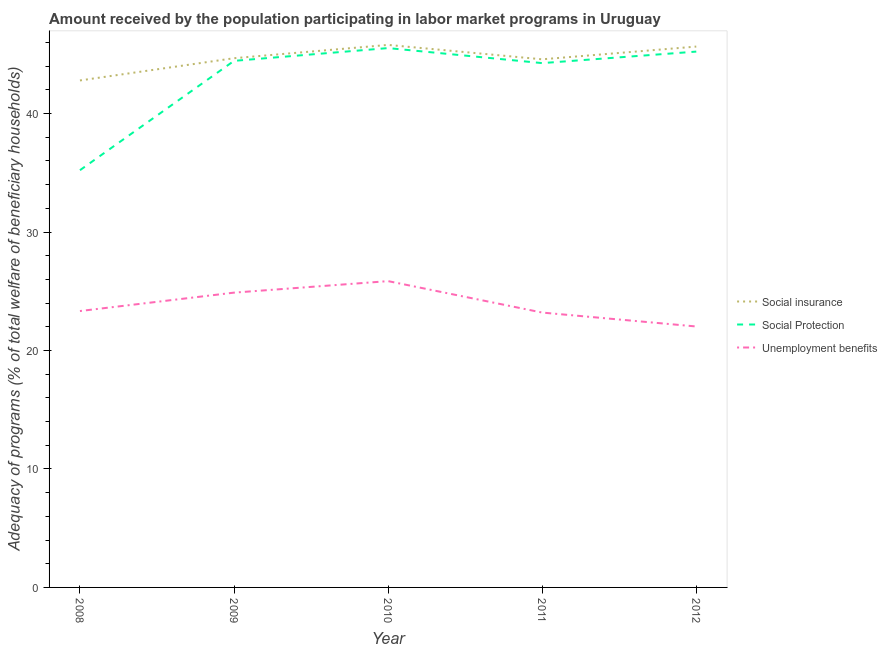How many different coloured lines are there?
Offer a terse response. 3. Does the line corresponding to amount received by the population participating in social protection programs intersect with the line corresponding to amount received by the population participating in social insurance programs?
Offer a very short reply. No. What is the amount received by the population participating in unemployment benefits programs in 2009?
Ensure brevity in your answer.  24.89. Across all years, what is the maximum amount received by the population participating in social protection programs?
Offer a very short reply. 45.53. Across all years, what is the minimum amount received by the population participating in social protection programs?
Provide a succinct answer. 35.22. In which year was the amount received by the population participating in social protection programs maximum?
Make the answer very short. 2010. What is the total amount received by the population participating in social insurance programs in the graph?
Offer a very short reply. 223.52. What is the difference between the amount received by the population participating in unemployment benefits programs in 2008 and that in 2010?
Give a very brief answer. -2.53. What is the difference between the amount received by the population participating in social protection programs in 2012 and the amount received by the population participating in social insurance programs in 2009?
Your answer should be very brief. 0.56. What is the average amount received by the population participating in unemployment benefits programs per year?
Your answer should be very brief. 23.86. In the year 2012, what is the difference between the amount received by the population participating in social protection programs and amount received by the population participating in unemployment benefits programs?
Ensure brevity in your answer.  23.21. What is the ratio of the amount received by the population participating in social protection programs in 2009 to that in 2012?
Make the answer very short. 0.98. Is the amount received by the population participating in unemployment benefits programs in 2010 less than that in 2011?
Your answer should be very brief. No. Is the difference between the amount received by the population participating in unemployment benefits programs in 2008 and 2011 greater than the difference between the amount received by the population participating in social protection programs in 2008 and 2011?
Your answer should be very brief. Yes. What is the difference between the highest and the second highest amount received by the population participating in social protection programs?
Make the answer very short. 0.3. What is the difference between the highest and the lowest amount received by the population participating in unemployment benefits programs?
Keep it short and to the point. 3.83. Is the sum of the amount received by the population participating in social insurance programs in 2009 and 2011 greater than the maximum amount received by the population participating in unemployment benefits programs across all years?
Your answer should be very brief. Yes. Does the amount received by the population participating in social protection programs monotonically increase over the years?
Offer a very short reply. No. How many years are there in the graph?
Your response must be concise. 5. Are the values on the major ticks of Y-axis written in scientific E-notation?
Keep it short and to the point. No. Does the graph contain grids?
Give a very brief answer. No. What is the title of the graph?
Offer a very short reply. Amount received by the population participating in labor market programs in Uruguay. What is the label or title of the Y-axis?
Ensure brevity in your answer.  Adequacy of programs (% of total welfare of beneficiary households). What is the Adequacy of programs (% of total welfare of beneficiary households) in Social insurance in 2008?
Give a very brief answer. 42.8. What is the Adequacy of programs (% of total welfare of beneficiary households) of Social Protection in 2008?
Your response must be concise. 35.22. What is the Adequacy of programs (% of total welfare of beneficiary households) in Unemployment benefits in 2008?
Offer a very short reply. 23.33. What is the Adequacy of programs (% of total welfare of beneficiary households) in Social insurance in 2009?
Provide a short and direct response. 44.68. What is the Adequacy of programs (% of total welfare of beneficiary households) in Social Protection in 2009?
Make the answer very short. 44.45. What is the Adequacy of programs (% of total welfare of beneficiary households) of Unemployment benefits in 2009?
Give a very brief answer. 24.89. What is the Adequacy of programs (% of total welfare of beneficiary households) in Social insurance in 2010?
Ensure brevity in your answer.  45.8. What is the Adequacy of programs (% of total welfare of beneficiary households) of Social Protection in 2010?
Provide a succinct answer. 45.53. What is the Adequacy of programs (% of total welfare of beneficiary households) in Unemployment benefits in 2010?
Your response must be concise. 25.86. What is the Adequacy of programs (% of total welfare of beneficiary households) in Social insurance in 2011?
Give a very brief answer. 44.58. What is the Adequacy of programs (% of total welfare of beneficiary households) of Social Protection in 2011?
Ensure brevity in your answer.  44.26. What is the Adequacy of programs (% of total welfare of beneficiary households) in Unemployment benefits in 2011?
Offer a terse response. 23.2. What is the Adequacy of programs (% of total welfare of beneficiary households) of Social insurance in 2012?
Provide a succinct answer. 45.66. What is the Adequacy of programs (% of total welfare of beneficiary households) of Social Protection in 2012?
Offer a very short reply. 45.24. What is the Adequacy of programs (% of total welfare of beneficiary households) in Unemployment benefits in 2012?
Your answer should be very brief. 22.03. Across all years, what is the maximum Adequacy of programs (% of total welfare of beneficiary households) of Social insurance?
Keep it short and to the point. 45.8. Across all years, what is the maximum Adequacy of programs (% of total welfare of beneficiary households) of Social Protection?
Your response must be concise. 45.53. Across all years, what is the maximum Adequacy of programs (% of total welfare of beneficiary households) of Unemployment benefits?
Ensure brevity in your answer.  25.86. Across all years, what is the minimum Adequacy of programs (% of total welfare of beneficiary households) in Social insurance?
Provide a succinct answer. 42.8. Across all years, what is the minimum Adequacy of programs (% of total welfare of beneficiary households) of Social Protection?
Your answer should be compact. 35.22. Across all years, what is the minimum Adequacy of programs (% of total welfare of beneficiary households) of Unemployment benefits?
Your answer should be very brief. 22.03. What is the total Adequacy of programs (% of total welfare of beneficiary households) of Social insurance in the graph?
Make the answer very short. 223.52. What is the total Adequacy of programs (% of total welfare of beneficiary households) of Social Protection in the graph?
Your answer should be compact. 214.71. What is the total Adequacy of programs (% of total welfare of beneficiary households) in Unemployment benefits in the graph?
Provide a short and direct response. 119.31. What is the difference between the Adequacy of programs (% of total welfare of beneficiary households) in Social insurance in 2008 and that in 2009?
Your answer should be very brief. -1.88. What is the difference between the Adequacy of programs (% of total welfare of beneficiary households) in Social Protection in 2008 and that in 2009?
Keep it short and to the point. -9.23. What is the difference between the Adequacy of programs (% of total welfare of beneficiary households) in Unemployment benefits in 2008 and that in 2009?
Ensure brevity in your answer.  -1.55. What is the difference between the Adequacy of programs (% of total welfare of beneficiary households) of Social insurance in 2008 and that in 2010?
Offer a terse response. -3. What is the difference between the Adequacy of programs (% of total welfare of beneficiary households) of Social Protection in 2008 and that in 2010?
Make the answer very short. -10.31. What is the difference between the Adequacy of programs (% of total welfare of beneficiary households) of Unemployment benefits in 2008 and that in 2010?
Your response must be concise. -2.53. What is the difference between the Adequacy of programs (% of total welfare of beneficiary households) in Social insurance in 2008 and that in 2011?
Your answer should be very brief. -1.78. What is the difference between the Adequacy of programs (% of total welfare of beneficiary households) of Social Protection in 2008 and that in 2011?
Your answer should be very brief. -9.04. What is the difference between the Adequacy of programs (% of total welfare of beneficiary households) of Unemployment benefits in 2008 and that in 2011?
Offer a very short reply. 0.13. What is the difference between the Adequacy of programs (% of total welfare of beneficiary households) in Social insurance in 2008 and that in 2012?
Ensure brevity in your answer.  -2.86. What is the difference between the Adequacy of programs (% of total welfare of beneficiary households) in Social Protection in 2008 and that in 2012?
Your answer should be compact. -10.01. What is the difference between the Adequacy of programs (% of total welfare of beneficiary households) in Unemployment benefits in 2008 and that in 2012?
Make the answer very short. 1.3. What is the difference between the Adequacy of programs (% of total welfare of beneficiary households) in Social insurance in 2009 and that in 2010?
Your response must be concise. -1.12. What is the difference between the Adequacy of programs (% of total welfare of beneficiary households) in Social Protection in 2009 and that in 2010?
Keep it short and to the point. -1.08. What is the difference between the Adequacy of programs (% of total welfare of beneficiary households) of Unemployment benefits in 2009 and that in 2010?
Ensure brevity in your answer.  -0.97. What is the difference between the Adequacy of programs (% of total welfare of beneficiary households) in Social insurance in 2009 and that in 2011?
Your response must be concise. 0.09. What is the difference between the Adequacy of programs (% of total welfare of beneficiary households) in Social Protection in 2009 and that in 2011?
Give a very brief answer. 0.19. What is the difference between the Adequacy of programs (% of total welfare of beneficiary households) in Unemployment benefits in 2009 and that in 2011?
Give a very brief answer. 1.68. What is the difference between the Adequacy of programs (% of total welfare of beneficiary households) of Social insurance in 2009 and that in 2012?
Give a very brief answer. -0.98. What is the difference between the Adequacy of programs (% of total welfare of beneficiary households) of Social Protection in 2009 and that in 2012?
Give a very brief answer. -0.78. What is the difference between the Adequacy of programs (% of total welfare of beneficiary households) of Unemployment benefits in 2009 and that in 2012?
Your response must be concise. 2.86. What is the difference between the Adequacy of programs (% of total welfare of beneficiary households) in Social insurance in 2010 and that in 2011?
Offer a very short reply. 1.22. What is the difference between the Adequacy of programs (% of total welfare of beneficiary households) of Social Protection in 2010 and that in 2011?
Keep it short and to the point. 1.27. What is the difference between the Adequacy of programs (% of total welfare of beneficiary households) in Unemployment benefits in 2010 and that in 2011?
Your response must be concise. 2.65. What is the difference between the Adequacy of programs (% of total welfare of beneficiary households) in Social insurance in 2010 and that in 2012?
Your answer should be very brief. 0.14. What is the difference between the Adequacy of programs (% of total welfare of beneficiary households) of Social Protection in 2010 and that in 2012?
Keep it short and to the point. 0.3. What is the difference between the Adequacy of programs (% of total welfare of beneficiary households) in Unemployment benefits in 2010 and that in 2012?
Your answer should be very brief. 3.83. What is the difference between the Adequacy of programs (% of total welfare of beneficiary households) in Social insurance in 2011 and that in 2012?
Your response must be concise. -1.08. What is the difference between the Adequacy of programs (% of total welfare of beneficiary households) of Social Protection in 2011 and that in 2012?
Offer a very short reply. -0.97. What is the difference between the Adequacy of programs (% of total welfare of beneficiary households) of Unemployment benefits in 2011 and that in 2012?
Keep it short and to the point. 1.17. What is the difference between the Adequacy of programs (% of total welfare of beneficiary households) in Social insurance in 2008 and the Adequacy of programs (% of total welfare of beneficiary households) in Social Protection in 2009?
Offer a very short reply. -1.65. What is the difference between the Adequacy of programs (% of total welfare of beneficiary households) in Social insurance in 2008 and the Adequacy of programs (% of total welfare of beneficiary households) in Unemployment benefits in 2009?
Offer a terse response. 17.91. What is the difference between the Adequacy of programs (% of total welfare of beneficiary households) in Social Protection in 2008 and the Adequacy of programs (% of total welfare of beneficiary households) in Unemployment benefits in 2009?
Provide a short and direct response. 10.34. What is the difference between the Adequacy of programs (% of total welfare of beneficiary households) of Social insurance in 2008 and the Adequacy of programs (% of total welfare of beneficiary households) of Social Protection in 2010?
Ensure brevity in your answer.  -2.73. What is the difference between the Adequacy of programs (% of total welfare of beneficiary households) in Social insurance in 2008 and the Adequacy of programs (% of total welfare of beneficiary households) in Unemployment benefits in 2010?
Offer a terse response. 16.94. What is the difference between the Adequacy of programs (% of total welfare of beneficiary households) in Social Protection in 2008 and the Adequacy of programs (% of total welfare of beneficiary households) in Unemployment benefits in 2010?
Make the answer very short. 9.36. What is the difference between the Adequacy of programs (% of total welfare of beneficiary households) in Social insurance in 2008 and the Adequacy of programs (% of total welfare of beneficiary households) in Social Protection in 2011?
Your response must be concise. -1.46. What is the difference between the Adequacy of programs (% of total welfare of beneficiary households) in Social insurance in 2008 and the Adequacy of programs (% of total welfare of beneficiary households) in Unemployment benefits in 2011?
Your response must be concise. 19.6. What is the difference between the Adequacy of programs (% of total welfare of beneficiary households) in Social Protection in 2008 and the Adequacy of programs (% of total welfare of beneficiary households) in Unemployment benefits in 2011?
Keep it short and to the point. 12.02. What is the difference between the Adequacy of programs (% of total welfare of beneficiary households) of Social insurance in 2008 and the Adequacy of programs (% of total welfare of beneficiary households) of Social Protection in 2012?
Your answer should be very brief. -2.44. What is the difference between the Adequacy of programs (% of total welfare of beneficiary households) in Social insurance in 2008 and the Adequacy of programs (% of total welfare of beneficiary households) in Unemployment benefits in 2012?
Give a very brief answer. 20.77. What is the difference between the Adequacy of programs (% of total welfare of beneficiary households) in Social Protection in 2008 and the Adequacy of programs (% of total welfare of beneficiary households) in Unemployment benefits in 2012?
Give a very brief answer. 13.19. What is the difference between the Adequacy of programs (% of total welfare of beneficiary households) in Social insurance in 2009 and the Adequacy of programs (% of total welfare of beneficiary households) in Social Protection in 2010?
Your response must be concise. -0.85. What is the difference between the Adequacy of programs (% of total welfare of beneficiary households) in Social insurance in 2009 and the Adequacy of programs (% of total welfare of beneficiary households) in Unemployment benefits in 2010?
Your answer should be compact. 18.82. What is the difference between the Adequacy of programs (% of total welfare of beneficiary households) of Social Protection in 2009 and the Adequacy of programs (% of total welfare of beneficiary households) of Unemployment benefits in 2010?
Offer a terse response. 18.6. What is the difference between the Adequacy of programs (% of total welfare of beneficiary households) in Social insurance in 2009 and the Adequacy of programs (% of total welfare of beneficiary households) in Social Protection in 2011?
Make the answer very short. 0.41. What is the difference between the Adequacy of programs (% of total welfare of beneficiary households) of Social insurance in 2009 and the Adequacy of programs (% of total welfare of beneficiary households) of Unemployment benefits in 2011?
Give a very brief answer. 21.47. What is the difference between the Adequacy of programs (% of total welfare of beneficiary households) in Social Protection in 2009 and the Adequacy of programs (% of total welfare of beneficiary households) in Unemployment benefits in 2011?
Provide a succinct answer. 21.25. What is the difference between the Adequacy of programs (% of total welfare of beneficiary households) in Social insurance in 2009 and the Adequacy of programs (% of total welfare of beneficiary households) in Social Protection in 2012?
Offer a very short reply. -0.56. What is the difference between the Adequacy of programs (% of total welfare of beneficiary households) of Social insurance in 2009 and the Adequacy of programs (% of total welfare of beneficiary households) of Unemployment benefits in 2012?
Your response must be concise. 22.65. What is the difference between the Adequacy of programs (% of total welfare of beneficiary households) in Social Protection in 2009 and the Adequacy of programs (% of total welfare of beneficiary households) in Unemployment benefits in 2012?
Provide a succinct answer. 22.42. What is the difference between the Adequacy of programs (% of total welfare of beneficiary households) of Social insurance in 2010 and the Adequacy of programs (% of total welfare of beneficiary households) of Social Protection in 2011?
Your response must be concise. 1.54. What is the difference between the Adequacy of programs (% of total welfare of beneficiary households) in Social insurance in 2010 and the Adequacy of programs (% of total welfare of beneficiary households) in Unemployment benefits in 2011?
Make the answer very short. 22.6. What is the difference between the Adequacy of programs (% of total welfare of beneficiary households) of Social Protection in 2010 and the Adequacy of programs (% of total welfare of beneficiary households) of Unemployment benefits in 2011?
Your answer should be very brief. 22.33. What is the difference between the Adequacy of programs (% of total welfare of beneficiary households) of Social insurance in 2010 and the Adequacy of programs (% of total welfare of beneficiary households) of Social Protection in 2012?
Your answer should be very brief. 0.56. What is the difference between the Adequacy of programs (% of total welfare of beneficiary households) in Social insurance in 2010 and the Adequacy of programs (% of total welfare of beneficiary households) in Unemployment benefits in 2012?
Make the answer very short. 23.77. What is the difference between the Adequacy of programs (% of total welfare of beneficiary households) in Social Protection in 2010 and the Adequacy of programs (% of total welfare of beneficiary households) in Unemployment benefits in 2012?
Keep it short and to the point. 23.5. What is the difference between the Adequacy of programs (% of total welfare of beneficiary households) in Social insurance in 2011 and the Adequacy of programs (% of total welfare of beneficiary households) in Social Protection in 2012?
Your response must be concise. -0.65. What is the difference between the Adequacy of programs (% of total welfare of beneficiary households) in Social insurance in 2011 and the Adequacy of programs (% of total welfare of beneficiary households) in Unemployment benefits in 2012?
Give a very brief answer. 22.55. What is the difference between the Adequacy of programs (% of total welfare of beneficiary households) in Social Protection in 2011 and the Adequacy of programs (% of total welfare of beneficiary households) in Unemployment benefits in 2012?
Your response must be concise. 22.23. What is the average Adequacy of programs (% of total welfare of beneficiary households) of Social insurance per year?
Ensure brevity in your answer.  44.7. What is the average Adequacy of programs (% of total welfare of beneficiary households) of Social Protection per year?
Your answer should be compact. 42.94. What is the average Adequacy of programs (% of total welfare of beneficiary households) of Unemployment benefits per year?
Give a very brief answer. 23.86. In the year 2008, what is the difference between the Adequacy of programs (% of total welfare of beneficiary households) in Social insurance and Adequacy of programs (% of total welfare of beneficiary households) in Social Protection?
Your answer should be compact. 7.58. In the year 2008, what is the difference between the Adequacy of programs (% of total welfare of beneficiary households) in Social insurance and Adequacy of programs (% of total welfare of beneficiary households) in Unemployment benefits?
Ensure brevity in your answer.  19.47. In the year 2008, what is the difference between the Adequacy of programs (% of total welfare of beneficiary households) in Social Protection and Adequacy of programs (% of total welfare of beneficiary households) in Unemployment benefits?
Your answer should be very brief. 11.89. In the year 2009, what is the difference between the Adequacy of programs (% of total welfare of beneficiary households) in Social insurance and Adequacy of programs (% of total welfare of beneficiary households) in Social Protection?
Ensure brevity in your answer.  0.22. In the year 2009, what is the difference between the Adequacy of programs (% of total welfare of beneficiary households) of Social insurance and Adequacy of programs (% of total welfare of beneficiary households) of Unemployment benefits?
Your answer should be very brief. 19.79. In the year 2009, what is the difference between the Adequacy of programs (% of total welfare of beneficiary households) of Social Protection and Adequacy of programs (% of total welfare of beneficiary households) of Unemployment benefits?
Offer a very short reply. 19.57. In the year 2010, what is the difference between the Adequacy of programs (% of total welfare of beneficiary households) in Social insurance and Adequacy of programs (% of total welfare of beneficiary households) in Social Protection?
Make the answer very short. 0.27. In the year 2010, what is the difference between the Adequacy of programs (% of total welfare of beneficiary households) in Social insurance and Adequacy of programs (% of total welfare of beneficiary households) in Unemployment benefits?
Keep it short and to the point. 19.94. In the year 2010, what is the difference between the Adequacy of programs (% of total welfare of beneficiary households) of Social Protection and Adequacy of programs (% of total welfare of beneficiary households) of Unemployment benefits?
Your answer should be very brief. 19.67. In the year 2011, what is the difference between the Adequacy of programs (% of total welfare of beneficiary households) in Social insurance and Adequacy of programs (% of total welfare of beneficiary households) in Social Protection?
Provide a succinct answer. 0.32. In the year 2011, what is the difference between the Adequacy of programs (% of total welfare of beneficiary households) in Social insurance and Adequacy of programs (% of total welfare of beneficiary households) in Unemployment benefits?
Provide a short and direct response. 21.38. In the year 2011, what is the difference between the Adequacy of programs (% of total welfare of beneficiary households) of Social Protection and Adequacy of programs (% of total welfare of beneficiary households) of Unemployment benefits?
Your response must be concise. 21.06. In the year 2012, what is the difference between the Adequacy of programs (% of total welfare of beneficiary households) in Social insurance and Adequacy of programs (% of total welfare of beneficiary households) in Social Protection?
Keep it short and to the point. 0.42. In the year 2012, what is the difference between the Adequacy of programs (% of total welfare of beneficiary households) of Social insurance and Adequacy of programs (% of total welfare of beneficiary households) of Unemployment benefits?
Give a very brief answer. 23.63. In the year 2012, what is the difference between the Adequacy of programs (% of total welfare of beneficiary households) in Social Protection and Adequacy of programs (% of total welfare of beneficiary households) in Unemployment benefits?
Provide a succinct answer. 23.21. What is the ratio of the Adequacy of programs (% of total welfare of beneficiary households) of Social insurance in 2008 to that in 2009?
Ensure brevity in your answer.  0.96. What is the ratio of the Adequacy of programs (% of total welfare of beneficiary households) of Social Protection in 2008 to that in 2009?
Your answer should be compact. 0.79. What is the ratio of the Adequacy of programs (% of total welfare of beneficiary households) of Unemployment benefits in 2008 to that in 2009?
Your answer should be very brief. 0.94. What is the ratio of the Adequacy of programs (% of total welfare of beneficiary households) of Social insurance in 2008 to that in 2010?
Your response must be concise. 0.93. What is the ratio of the Adequacy of programs (% of total welfare of beneficiary households) in Social Protection in 2008 to that in 2010?
Your answer should be very brief. 0.77. What is the ratio of the Adequacy of programs (% of total welfare of beneficiary households) in Unemployment benefits in 2008 to that in 2010?
Provide a succinct answer. 0.9. What is the ratio of the Adequacy of programs (% of total welfare of beneficiary households) in Social Protection in 2008 to that in 2011?
Your response must be concise. 0.8. What is the ratio of the Adequacy of programs (% of total welfare of beneficiary households) of Unemployment benefits in 2008 to that in 2011?
Provide a short and direct response. 1.01. What is the ratio of the Adequacy of programs (% of total welfare of beneficiary households) of Social insurance in 2008 to that in 2012?
Your answer should be compact. 0.94. What is the ratio of the Adequacy of programs (% of total welfare of beneficiary households) of Social Protection in 2008 to that in 2012?
Keep it short and to the point. 0.78. What is the ratio of the Adequacy of programs (% of total welfare of beneficiary households) in Unemployment benefits in 2008 to that in 2012?
Provide a succinct answer. 1.06. What is the ratio of the Adequacy of programs (% of total welfare of beneficiary households) in Social insurance in 2009 to that in 2010?
Offer a terse response. 0.98. What is the ratio of the Adequacy of programs (% of total welfare of beneficiary households) of Social Protection in 2009 to that in 2010?
Provide a succinct answer. 0.98. What is the ratio of the Adequacy of programs (% of total welfare of beneficiary households) in Unemployment benefits in 2009 to that in 2010?
Offer a terse response. 0.96. What is the ratio of the Adequacy of programs (% of total welfare of beneficiary households) of Social insurance in 2009 to that in 2011?
Your answer should be compact. 1. What is the ratio of the Adequacy of programs (% of total welfare of beneficiary households) of Social Protection in 2009 to that in 2011?
Your answer should be compact. 1. What is the ratio of the Adequacy of programs (% of total welfare of beneficiary households) of Unemployment benefits in 2009 to that in 2011?
Give a very brief answer. 1.07. What is the ratio of the Adequacy of programs (% of total welfare of beneficiary households) in Social insurance in 2009 to that in 2012?
Your answer should be compact. 0.98. What is the ratio of the Adequacy of programs (% of total welfare of beneficiary households) in Social Protection in 2009 to that in 2012?
Your response must be concise. 0.98. What is the ratio of the Adequacy of programs (% of total welfare of beneficiary households) of Unemployment benefits in 2009 to that in 2012?
Your answer should be compact. 1.13. What is the ratio of the Adequacy of programs (% of total welfare of beneficiary households) of Social insurance in 2010 to that in 2011?
Make the answer very short. 1.03. What is the ratio of the Adequacy of programs (% of total welfare of beneficiary households) of Social Protection in 2010 to that in 2011?
Offer a terse response. 1.03. What is the ratio of the Adequacy of programs (% of total welfare of beneficiary households) in Unemployment benefits in 2010 to that in 2011?
Your response must be concise. 1.11. What is the ratio of the Adequacy of programs (% of total welfare of beneficiary households) of Social Protection in 2010 to that in 2012?
Your response must be concise. 1.01. What is the ratio of the Adequacy of programs (% of total welfare of beneficiary households) of Unemployment benefits in 2010 to that in 2012?
Make the answer very short. 1.17. What is the ratio of the Adequacy of programs (% of total welfare of beneficiary households) of Social insurance in 2011 to that in 2012?
Give a very brief answer. 0.98. What is the ratio of the Adequacy of programs (% of total welfare of beneficiary households) in Social Protection in 2011 to that in 2012?
Ensure brevity in your answer.  0.98. What is the ratio of the Adequacy of programs (% of total welfare of beneficiary households) of Unemployment benefits in 2011 to that in 2012?
Your answer should be compact. 1.05. What is the difference between the highest and the second highest Adequacy of programs (% of total welfare of beneficiary households) in Social insurance?
Your answer should be compact. 0.14. What is the difference between the highest and the second highest Adequacy of programs (% of total welfare of beneficiary households) in Social Protection?
Provide a short and direct response. 0.3. What is the difference between the highest and the second highest Adequacy of programs (% of total welfare of beneficiary households) of Unemployment benefits?
Provide a succinct answer. 0.97. What is the difference between the highest and the lowest Adequacy of programs (% of total welfare of beneficiary households) of Social insurance?
Offer a terse response. 3. What is the difference between the highest and the lowest Adequacy of programs (% of total welfare of beneficiary households) in Social Protection?
Ensure brevity in your answer.  10.31. What is the difference between the highest and the lowest Adequacy of programs (% of total welfare of beneficiary households) of Unemployment benefits?
Offer a terse response. 3.83. 